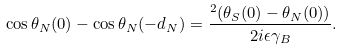Convert formula to latex. <formula><loc_0><loc_0><loc_500><loc_500>\cos \theta _ { N } ( 0 ) - \cos \theta _ { N } ( - d _ { N } ) = \frac { ^ { 2 } ( \theta _ { S } ( 0 ) - \theta _ { N } ( 0 ) ) } { 2 i \epsilon \gamma _ { B } } .</formula> 